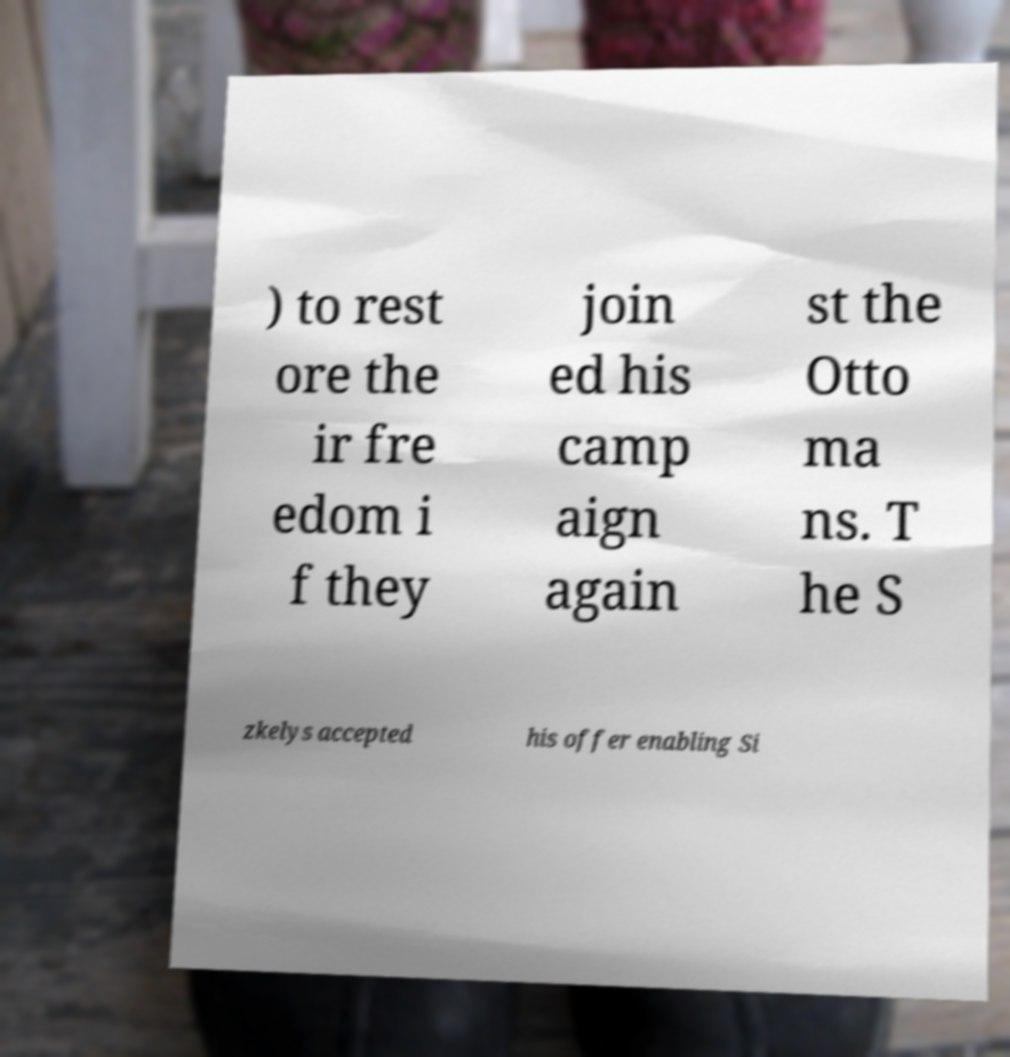Can you accurately transcribe the text from the provided image for me? ) to rest ore the ir fre edom i f they join ed his camp aign again st the Otto ma ns. T he S zkelys accepted his offer enabling Si 